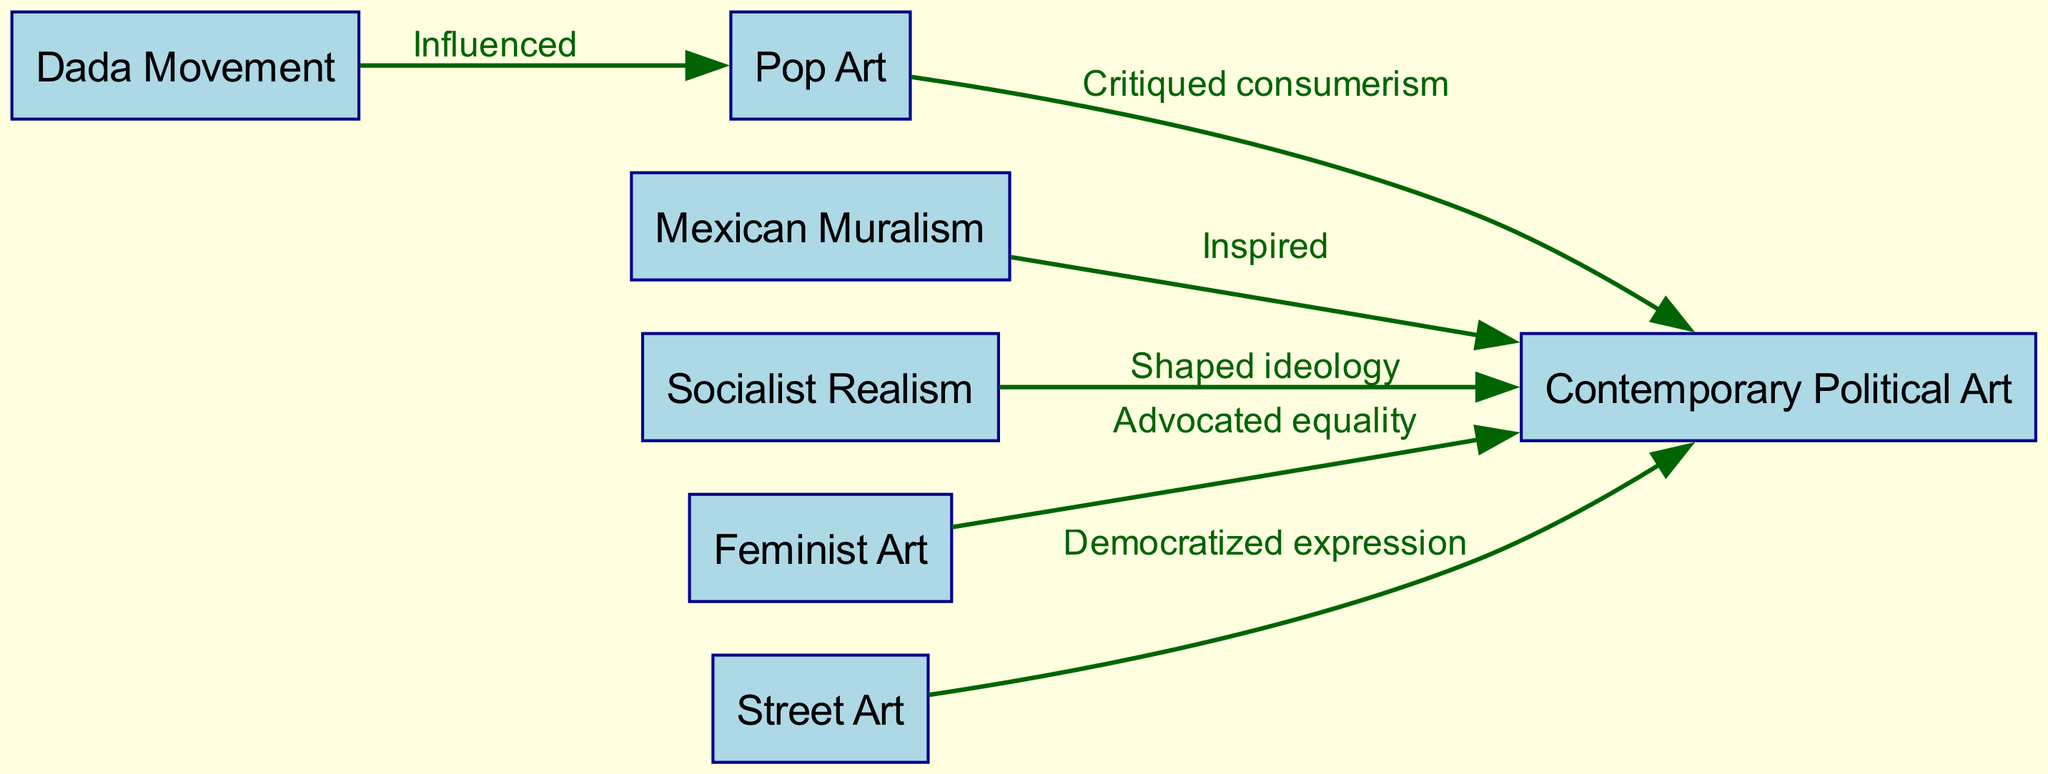What's the total number of nodes in the diagram? There are 7 nodes listed: Dada Movement, Mexican Muralism, Socialist Realism, Pop Art, Feminist Art, Street Art, and Contemporary Political Art. Counting these gives a total of 7 nodes.
Answer: 7 Which movement is connected to Pop Art by an "Influenced" label? The Dada Movement has an edge labeled "Influenced" pointing to Pop Art, indicating that it had an impact on this movement.
Answer: Dada Movement How many edges connect to Contemporary Political Art? There are 5 edges connecting various art movements to Contemporary Political Art: from Mexican Muralism, Socialist Realism, Pop Art, Feminist Art, and Street Art. Counting these gives a total of 5 edges.
Answer: 5 What relationship connects Feminist Art and Contemporary Political Art? The relationship is denoted as "Advocated equality," meaning Feminist Art supports the concept of equality, which influences Contemporary Political Art.
Answer: Advocated equality What two movements shape the ideology of Contemporary Political Art? Socialist Realism is identified as shaping the ideology of Contemporary Political Art, along with Mexican Muralism, which inspired it.
Answer: Socialist Realism, Mexican Muralism Which movement critiques consumerism according to the diagram? Pop Art is shown to have an edge leading to Contemporary Political Art with the label "Critiqued consumerism," indicating its stance against consumer culture.
Answer: Pop Art What type of expression does Street Art promote towards Contemporary Political Art? Street Art is labeled with "Democratized expression," emphasizing its role in making artistic expression accessible to the general public and influencing Contemporary Political Art.
Answer: Democratized expression 